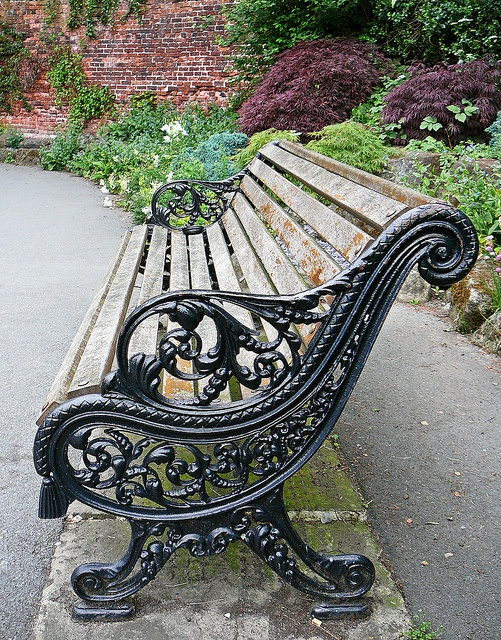Describe the objects in this image and their specific colors. I can see a bench in gray, black, lightgray, and darkgray tones in this image. 